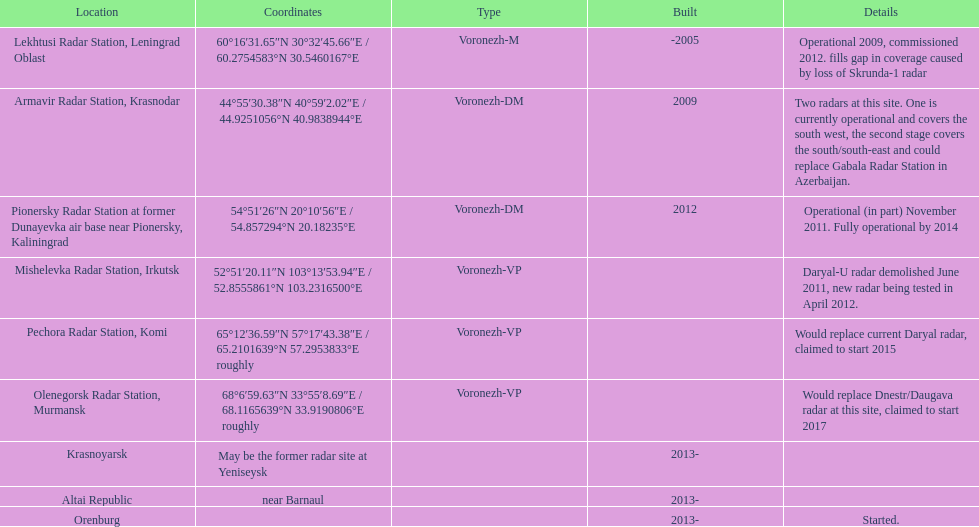2754583°n 3 Lekhtusi Radar Station, Leningrad Oblast. 